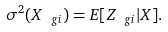Convert formula to latex. <formula><loc_0><loc_0><loc_500><loc_500>\sigma ^ { 2 } ( X _ { \ g i } ) = E [ Z _ { \ g i } | { X } ] .</formula> 